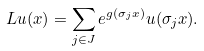<formula> <loc_0><loc_0><loc_500><loc_500>\L L u ( x ) = \sum _ { j \in J } e ^ { g ( \sigma _ { j } x ) } u ( \sigma _ { j } x ) .</formula> 